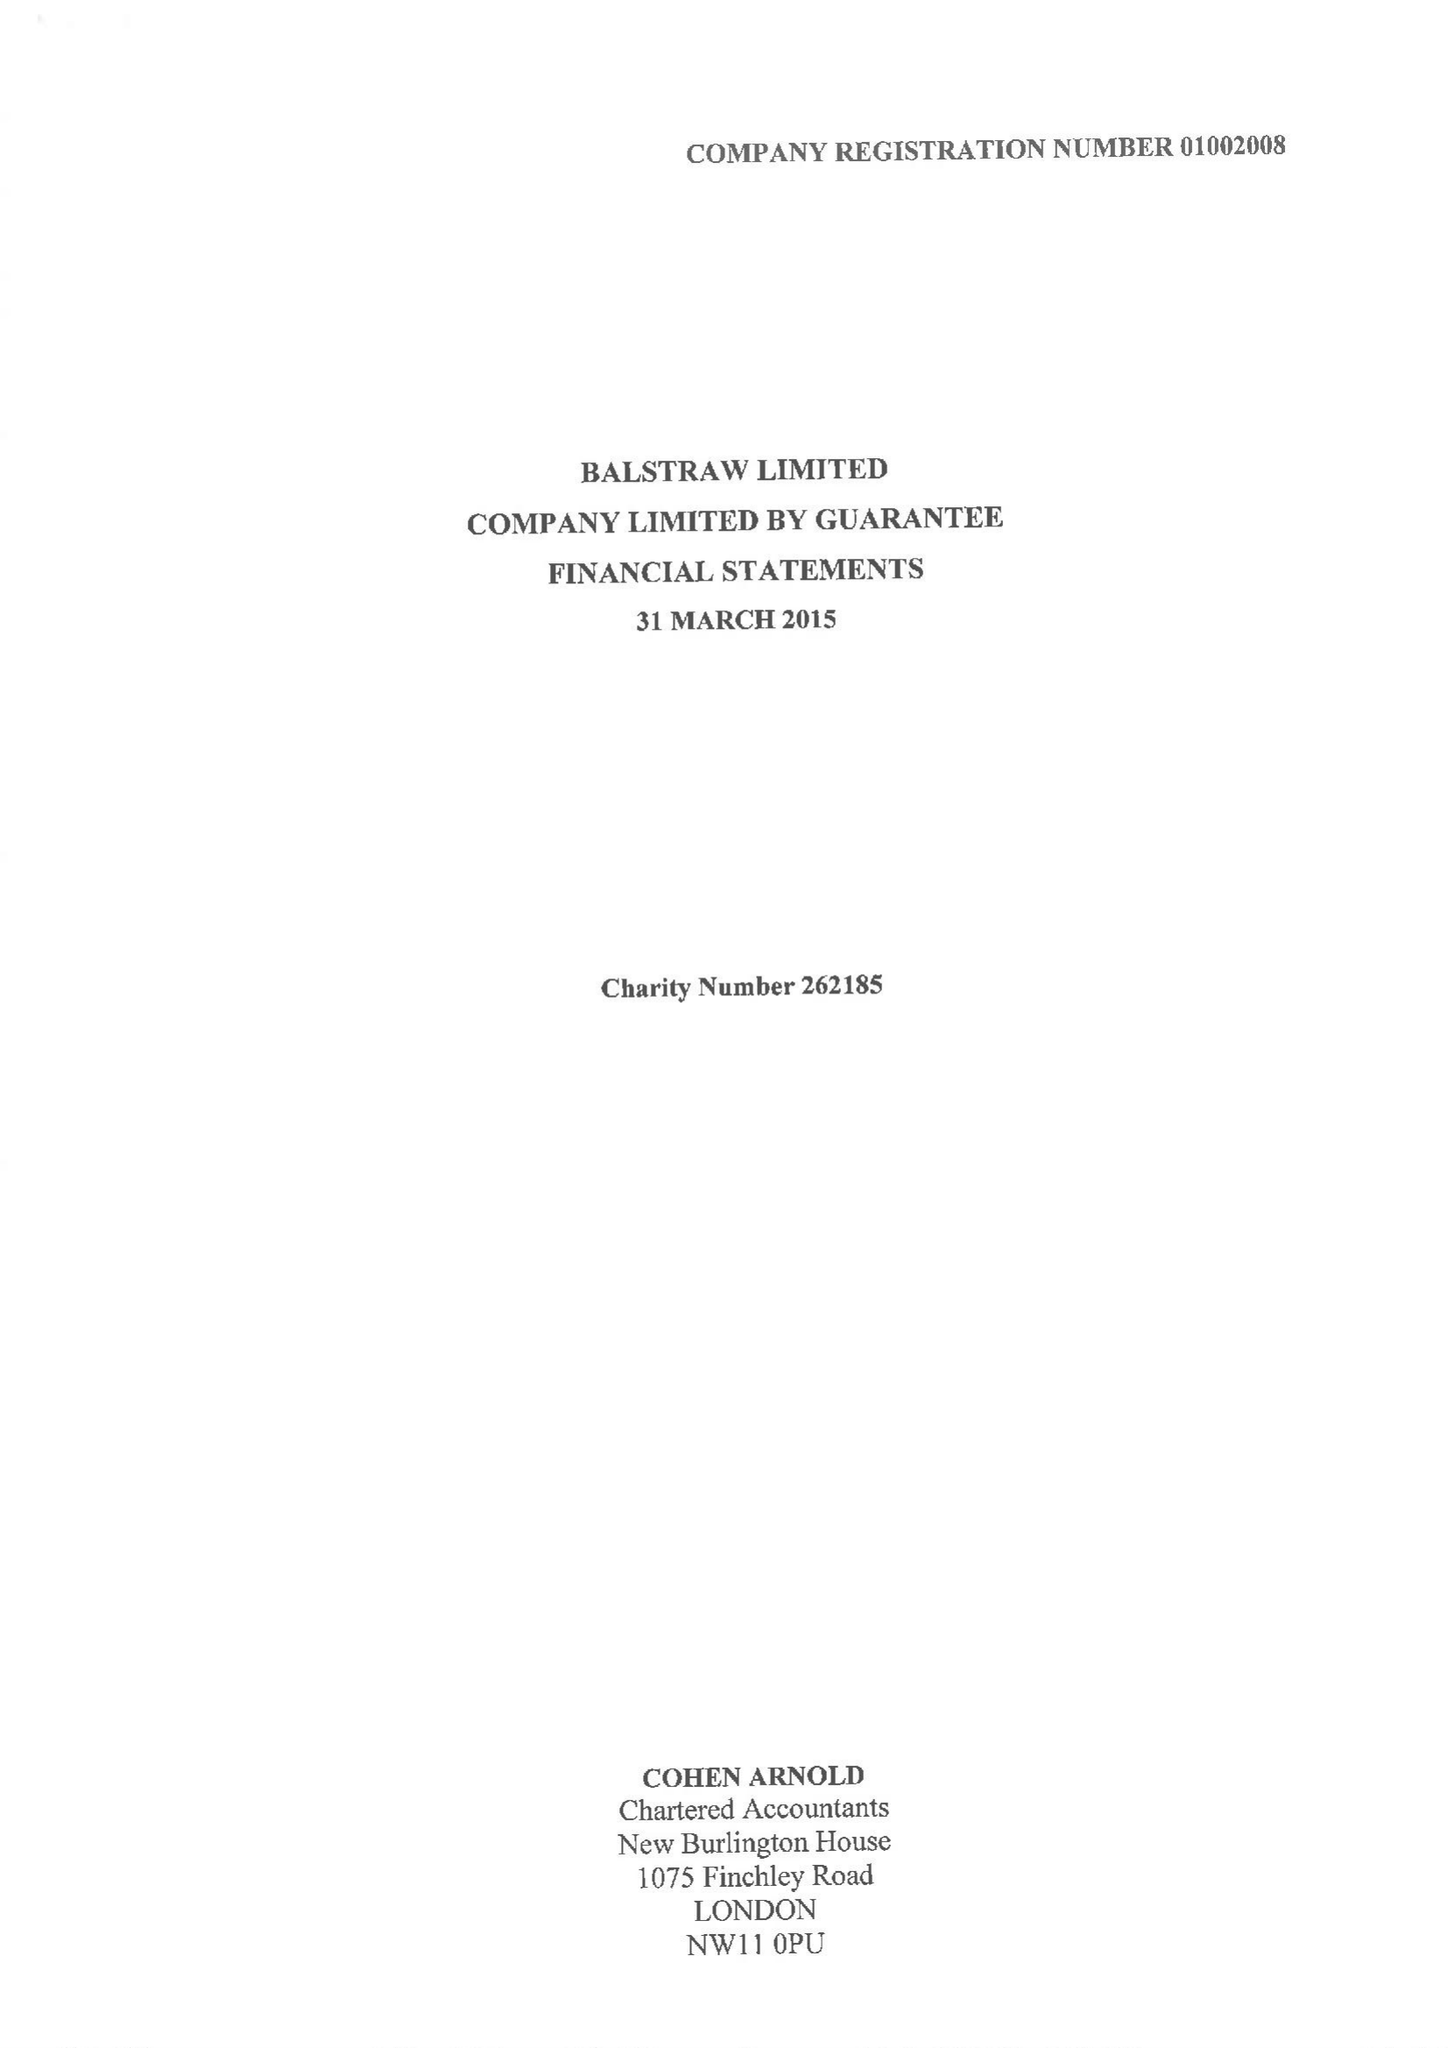What is the value for the spending_annually_in_british_pounds?
Answer the question using a single word or phrase. 230987.00 